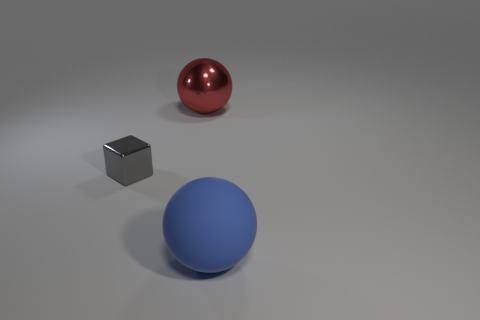What number of other objects are there of the same shape as the small gray thing?
Make the answer very short. 0. There is a big sphere behind the cube; is it the same color as the metallic cube?
Provide a short and direct response. No. What number of other things are the same size as the blue sphere?
Your answer should be very brief. 1. Are the gray thing and the big red object made of the same material?
Ensure brevity in your answer.  Yes. There is a tiny cube left of the big thing behind the blue thing; what color is it?
Ensure brevity in your answer.  Gray. What size is the blue thing that is the same shape as the red object?
Ensure brevity in your answer.  Large. Do the rubber object and the large metal sphere have the same color?
Keep it short and to the point. No. There is a ball right of the metallic thing that is behind the gray cube; how many tiny things are in front of it?
Provide a succinct answer. 0. Is the number of small purple matte balls greater than the number of blue things?
Provide a short and direct response. No. What number of spheres are there?
Make the answer very short. 2. 